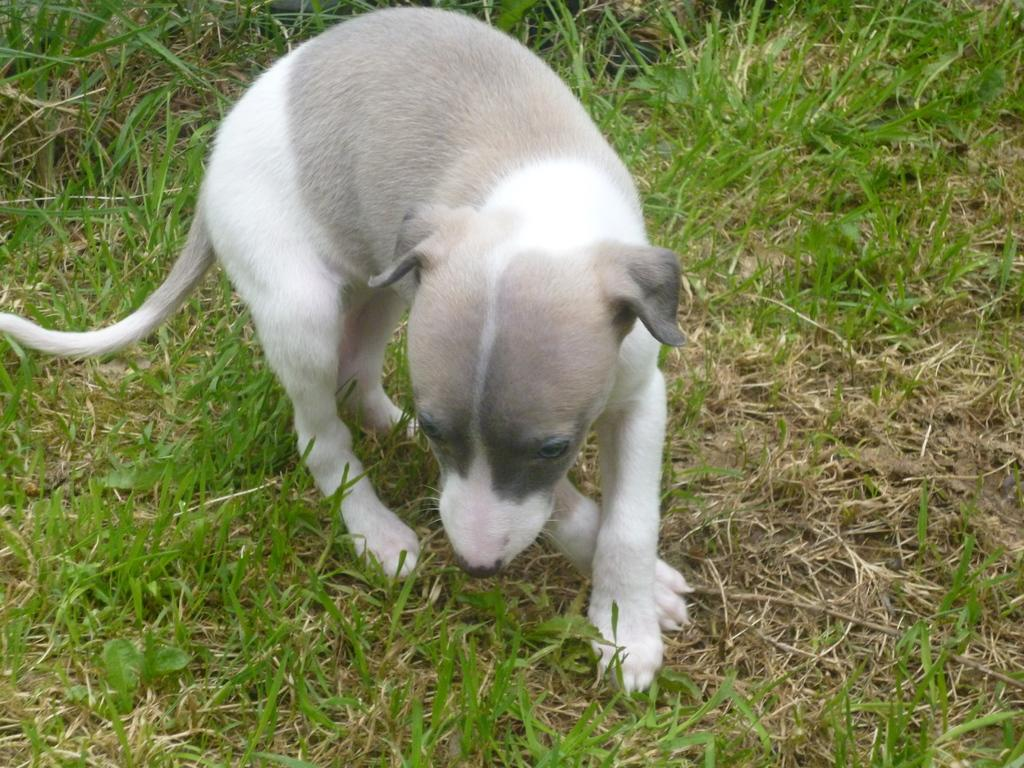What animal can be seen in the image? There is a dog in the image. What is the dog doing in the image? The dog is walking in the image. Where is the dog walking? The dog is on the grass in the image. What type of sack is the dog carrying on its neck in the image? There is no sack or any object on the dog's neck in the image. How much quartz can be seen in the image? There is no quartz present in the image. 